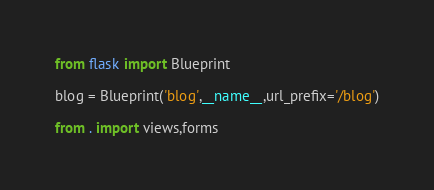Convert code to text. <code><loc_0><loc_0><loc_500><loc_500><_Python_>from flask import Blueprint

blog = Blueprint('blog',__name__,url_prefix='/blog')

from . import views,forms</code> 